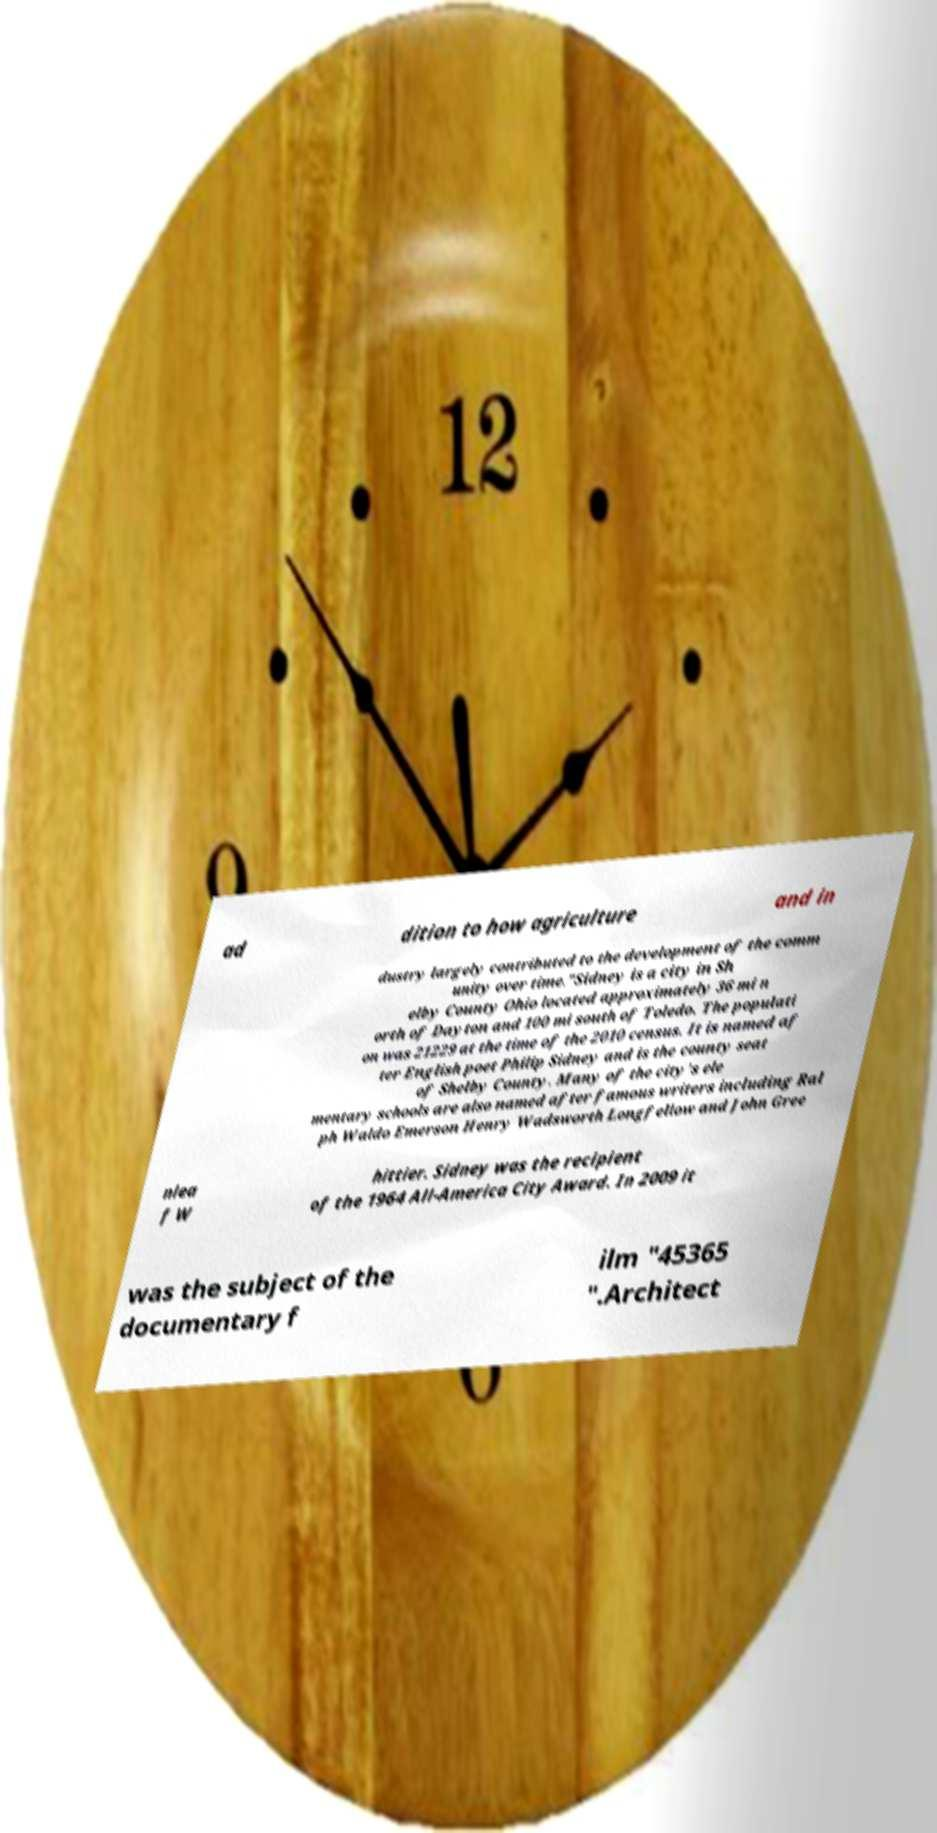I need the written content from this picture converted into text. Can you do that? ad dition to how agriculture and in dustry largely contributed to the development of the comm unity over time."Sidney is a city in Sh elby County Ohio located approximately 36 mi n orth of Dayton and 100 mi south of Toledo. The populati on was 21229 at the time of the 2010 census. It is named af ter English poet Philip Sidney and is the county seat of Shelby County. Many of the city's ele mentary schools are also named after famous writers including Ral ph Waldo Emerson Henry Wadsworth Longfellow and John Gree nlea f W hittier. Sidney was the recipient of the 1964 All-America City Award. In 2009 it was the subject of the documentary f ilm "45365 ".Architect 